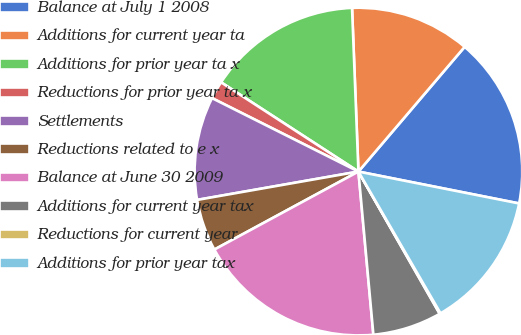<chart> <loc_0><loc_0><loc_500><loc_500><pie_chart><fcel>Balance at July 1 2008<fcel>Additions for current year ta<fcel>Additions for prior year ta x<fcel>Reductions for prior year ta x<fcel>Settlements<fcel>Reductions related to e x<fcel>Balance at June 30 2009<fcel>Additions for current year tax<fcel>Reductions for current year<fcel>Additions for prior year tax<nl><fcel>16.89%<fcel>11.85%<fcel>15.21%<fcel>1.77%<fcel>10.17%<fcel>5.13%<fcel>18.56%<fcel>6.81%<fcel>0.09%<fcel>13.53%<nl></chart> 